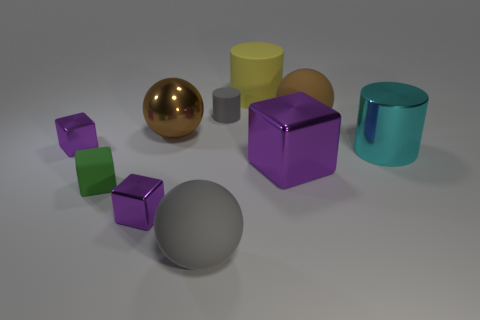What shape is the gray thing that is the same size as the green matte cube?
Ensure brevity in your answer.  Cylinder. What number of things are big matte cylinders or cubes left of the green matte block?
Provide a short and direct response. 2. Is the small purple object in front of the small rubber cube made of the same material as the tiny block behind the big purple cube?
Your answer should be compact. Yes. There is a object that is the same color as the metal sphere; what is its shape?
Offer a terse response. Sphere. What number of purple objects are either large cubes or metallic cylinders?
Your answer should be very brief. 1. How big is the green object?
Offer a very short reply. Small. Is the number of purple things that are behind the green matte object greater than the number of large brown shiny cylinders?
Ensure brevity in your answer.  Yes. What number of green things are behind the brown metal thing?
Your response must be concise. 0. Are there any green blocks of the same size as the yellow cylinder?
Offer a very short reply. No. What is the color of the other tiny rubber thing that is the same shape as the yellow object?
Your answer should be compact. Gray. 